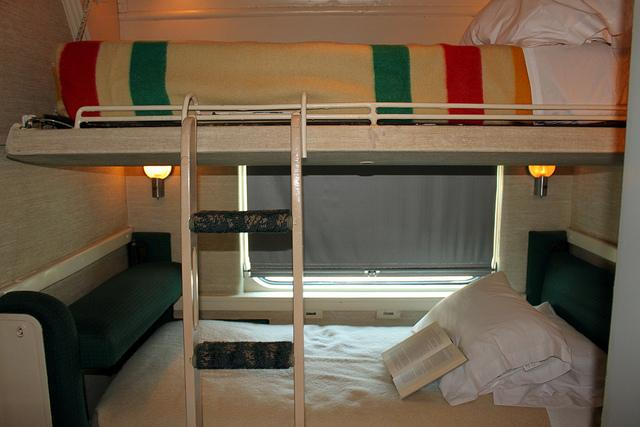Where might these sleeping quarters be located?

Choices:
A) home
B) train
C) bus
D) car train 